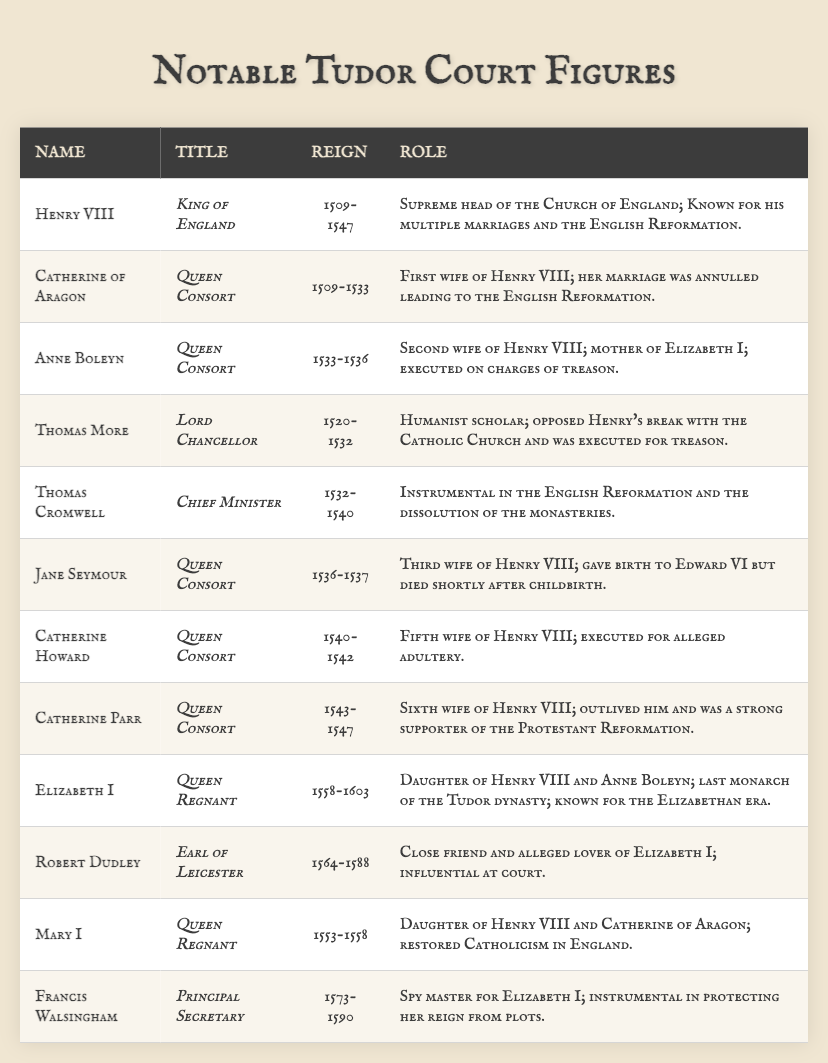What role did Thomas More hold during his time? The table indicates that Thomas More was the Lord Chancellor, which is explicitly stated in the "Title" column next to his name.
Answer: Lord Chancellor Which queen consort was executed for treason? According to the table, Anne Boleyn is noted in the "Role" column as having been executed on charges of treason.
Answer: Anne Boleyn Who was the last monarch of the Tudor dynasty? The table lists Elizabeth I as the Queen Regnant and marks her as the last monarch of the Tudor dynasty in her "Role".
Answer: Elizabeth I How many wives did Henry VIII have, according to the table? The table lists six individuals identified as queens consort of Henry VIII: Catherine of Aragon, Anne Boleyn, Jane Seymour, Catherine Howard, and Catherine Parr. Therefore, he had five wives.
Answer: Five Did Mary I restore Protestantism in England? The table states that Mary I restored Catholicism in England, which directly contradicts the claim that she restored Protestantism.
Answer: No What was the reign period of Catherine of Aragon? The reign period of Catherine of Aragon is indicated in the table as 1509-1533, which can be found in the "Reign" column under her name.
Answer: 1509-1533 Which figure was involved in the dissolution of the monasteries? The table shows that Thomas Cromwell was the Chief Minister and was instrumental in the dissolution of the monasteries, as stated in his "Role".
Answer: Thomas Cromwell Was Robert Dudley influential at court? The table explicitly states that Robert Dudley was influential at court in his "Role" description.
Answer: Yes Who succeeded Mary I on the throne? Looking at the table, Elizabeth I follows Mary I, indicating that she was her successor as Queen Regnant.
Answer: Elizabeth I What was the primary role of Francis Walsingham? The table identifies Francis Walsingham as the Principal Secretary and states that he was instrumental in protecting Elizabeth I’s reign from plots, detailing his role.
Answer: Principal Secretary 